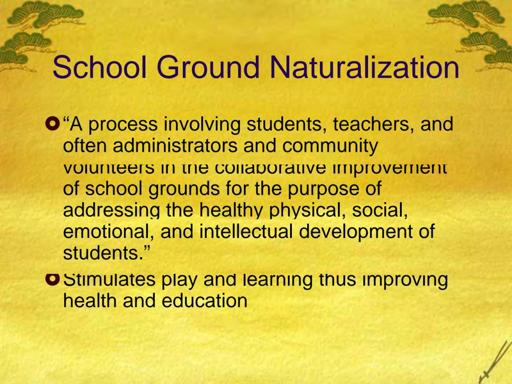How does naturalization of school grounds affect local wildlife? Naturalization of school grounds can have a positive impact on local wildlife by creating habitats that attract various species. By planting native flora, these naturalized areas provide food, shelter, and breeding sites for local birds, insects, and small mammals. This biodiversity not only enriches the ecological health of the area but also offers students unique opportunities to observe and study wildlife up close, fostering a lifelong appreciation for nature. 